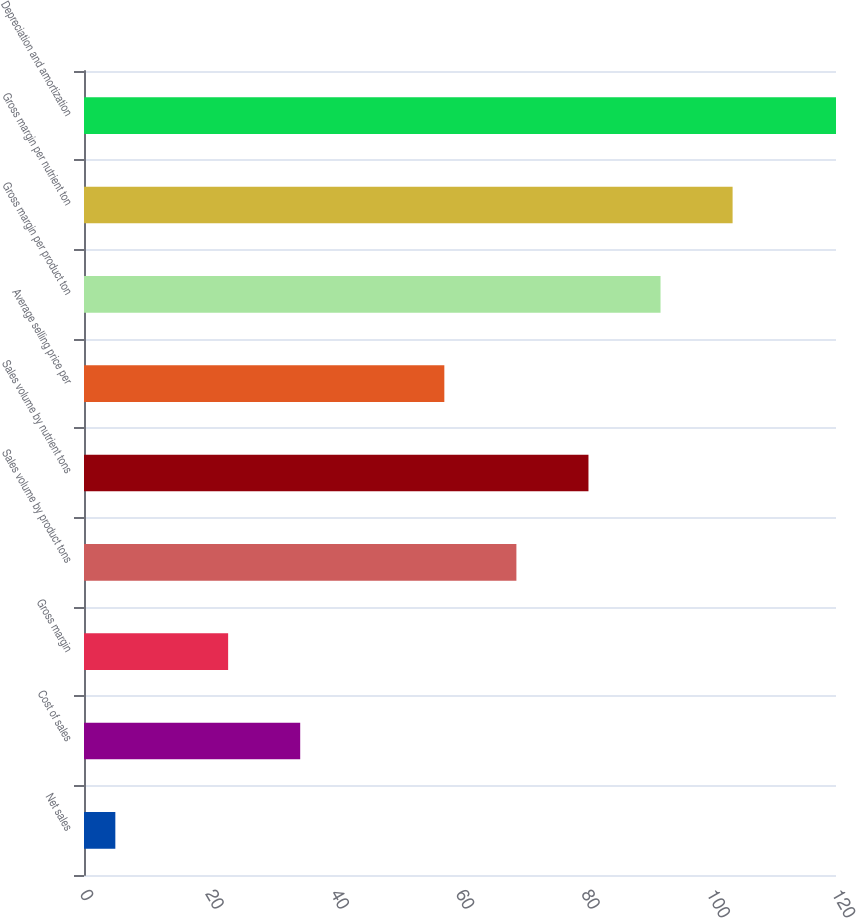Convert chart to OTSL. <chart><loc_0><loc_0><loc_500><loc_500><bar_chart><fcel>Net sales<fcel>Cost of sales<fcel>Gross margin<fcel>Sales volume by product tons<fcel>Sales volume by nutrient tons<fcel>Average selling price per<fcel>Gross margin per product ton<fcel>Gross margin per nutrient ton<fcel>Depreciation and amortization<nl><fcel>5<fcel>34.5<fcel>23<fcel>69<fcel>80.5<fcel>57.5<fcel>92<fcel>103.5<fcel>120<nl></chart> 